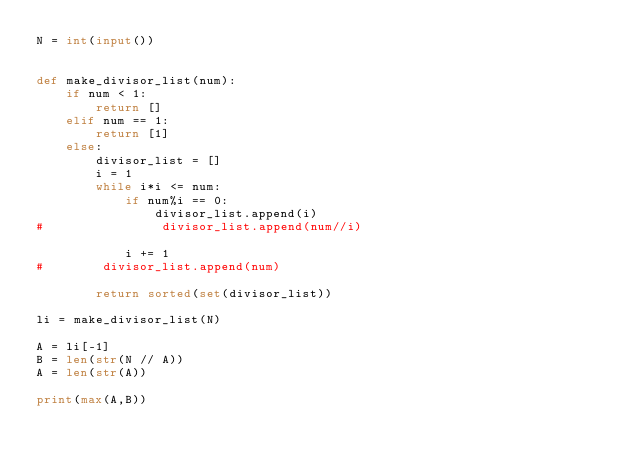<code> <loc_0><loc_0><loc_500><loc_500><_Python_>N = int(input())


def make_divisor_list(num):
    if num < 1:
        return []
    elif num == 1:
        return [1]
    else:
        divisor_list = []
        i = 1
        while i*i <= num:
            if num%i == 0:
                divisor_list.append(i)
#                divisor_list.append(num//i)

            i += 1
#        divisor_list.append(num)

        return sorted(set(divisor_list))

li = make_divisor_list(N)

A = li[-1]
B = len(str(N // A))
A = len(str(A))

print(max(A,B))
</code> 